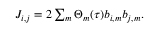Convert formula to latex. <formula><loc_0><loc_0><loc_500><loc_500>\begin{array} { r } { J _ { i , j } = 2 \sum _ { m } \Theta _ { m } ( \tau ) b _ { i , m } b _ { j , m } . } \end{array}</formula> 